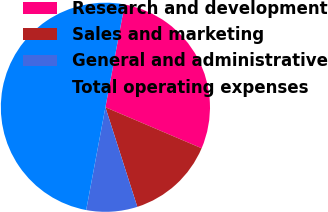Convert chart to OTSL. <chart><loc_0><loc_0><loc_500><loc_500><pie_chart><fcel>Research and development<fcel>Sales and marketing<fcel>General and administrative<fcel>Total operating expenses<nl><fcel>28.47%<fcel>13.65%<fcel>7.88%<fcel>50.0%<nl></chart> 